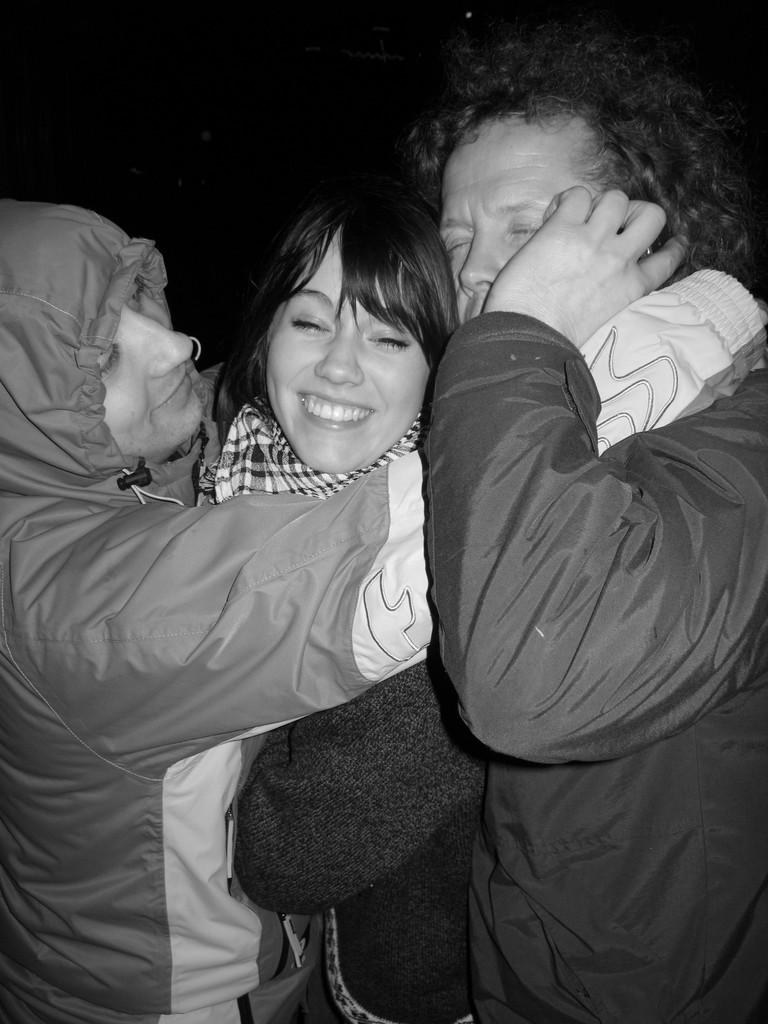How many people are in the image? There are three people in the image. What are the people doing in the image? The people are hugging one another. What color is the background of the image? The background of the image is black. What type of linen can be seen draped over the bikes in the image? There are no bikes or linen present in the image; it features three people hugging one another with a black background. 